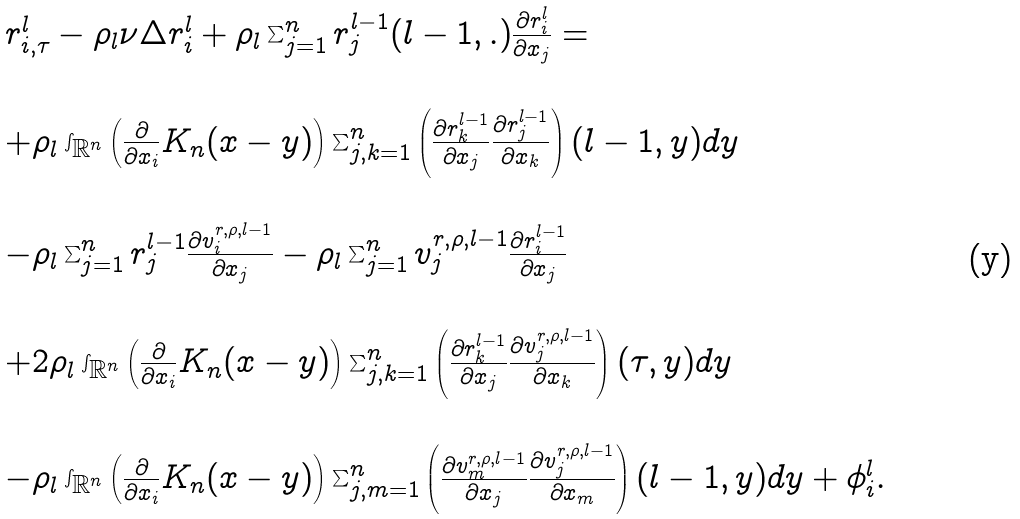Convert formula to latex. <formula><loc_0><loc_0><loc_500><loc_500>\begin{array} { l l } r ^ { l } _ { i , \tau } - \rho _ { l } \nu \Delta r ^ { l } _ { i } + \rho _ { l } \sum _ { j = 1 } ^ { n } r ^ { l - 1 } _ { j } ( l - 1 , . ) \frac { \partial r ^ { l } _ { i } } { \partial x _ { j } } = \\ \\ + \rho _ { l } \int _ { { \mathbb { R } } ^ { n } } \left ( \frac { \partial } { \partial x _ { i } } K _ { n } ( x - y ) \right ) \sum _ { j , k = 1 } ^ { n } \left ( \frac { \partial r ^ { l - 1 } _ { k } } { \partial x _ { j } } \frac { \partial r ^ { l - 1 } _ { j } } { \partial x _ { k } } \right ) ( l - 1 , y ) d y \\ \\ - \rho _ { l } \sum _ { j = 1 } ^ { n } r ^ { l - 1 } _ { j } \frac { \partial v ^ { r , \rho , l - 1 } _ { i } } { \partial x _ { j } } - \rho _ { l } \sum _ { j = 1 } ^ { n } v ^ { r , \rho , l - 1 } _ { j } \frac { \partial r ^ { l - 1 } _ { i } } { \partial x _ { j } } \\ \\ + 2 \rho _ { l } \int _ { { \mathbb { R } } ^ { n } } \left ( \frac { \partial } { \partial x _ { i } } K _ { n } ( x - y ) \right ) \sum _ { j , k = 1 } ^ { n } \left ( \frac { \partial r ^ { l - 1 } _ { k } } { \partial x _ { j } } \frac { \partial v ^ { r , \rho , l - 1 } _ { j } } { \partial x _ { k } } \right ) ( \tau , y ) d y \\ \\ - \rho _ { l } \int _ { { \mathbb { R } } ^ { n } } \left ( \frac { \partial } { \partial x _ { i } } K _ { n } ( x - y ) \right ) \sum _ { j , m = 1 } ^ { n } \left ( \frac { \partial v ^ { r , \rho , l - 1 } _ { m } } { \partial x _ { j } } \frac { \partial v ^ { r , \rho , l - 1 } _ { j } } { \partial x _ { m } } \right ) ( l - 1 , y ) d y + \phi ^ { l } _ { i } . \end{array}</formula> 